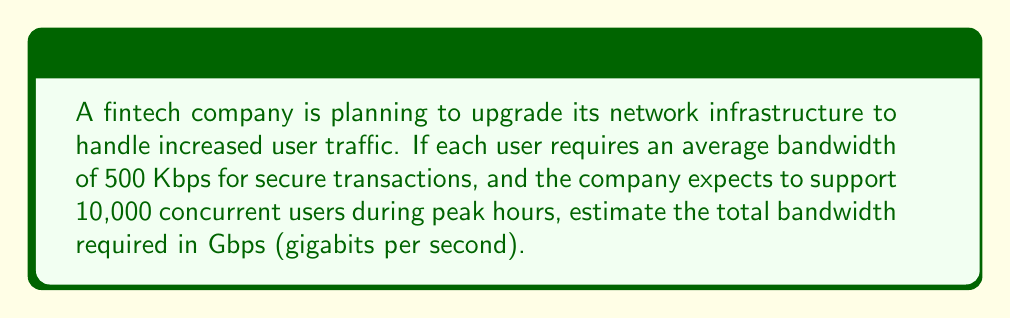Give your solution to this math problem. To solve this problem, we'll follow these steps:

1. Calculate the total bandwidth required in Kbps:
   $$\text{Total Bandwidth (Kbps)} = \text{Bandwidth per user} \times \text{Number of concurrent users}$$
   $$\text{Total Bandwidth (Kbps)} = 500 \text{ Kbps} \times 10,000 = 5,000,000 \text{ Kbps}$$

2. Convert Kbps to Gbps:
   We know that 1 Gbps = 1,000,000 Kbps
   
   To convert, we divide the total bandwidth in Kbps by 1,000,000:
   $$\text{Total Bandwidth (Gbps)} = \frac{5,000,000 \text{ Kbps}}{1,000,000 \text{ Kbps/Gbps}} = 5 \text{ Gbps}$$

Therefore, the estimated bandwidth required for 10,000 concurrent users is 5 Gbps.
Answer: 5 Gbps 